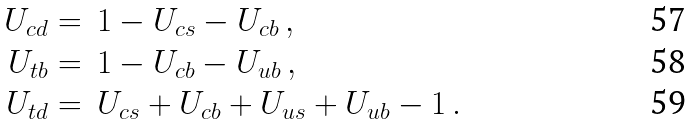<formula> <loc_0><loc_0><loc_500><loc_500>U _ { c d } & = \, 1 - U _ { c s } - U _ { c b } \, , \\ U _ { t b } & = \, 1 - U _ { c b } - U _ { u b } \, , \\ U _ { t d } & = \, U _ { c s } + U _ { c b } + U _ { u s } + U _ { u b } - 1 \, .</formula> 